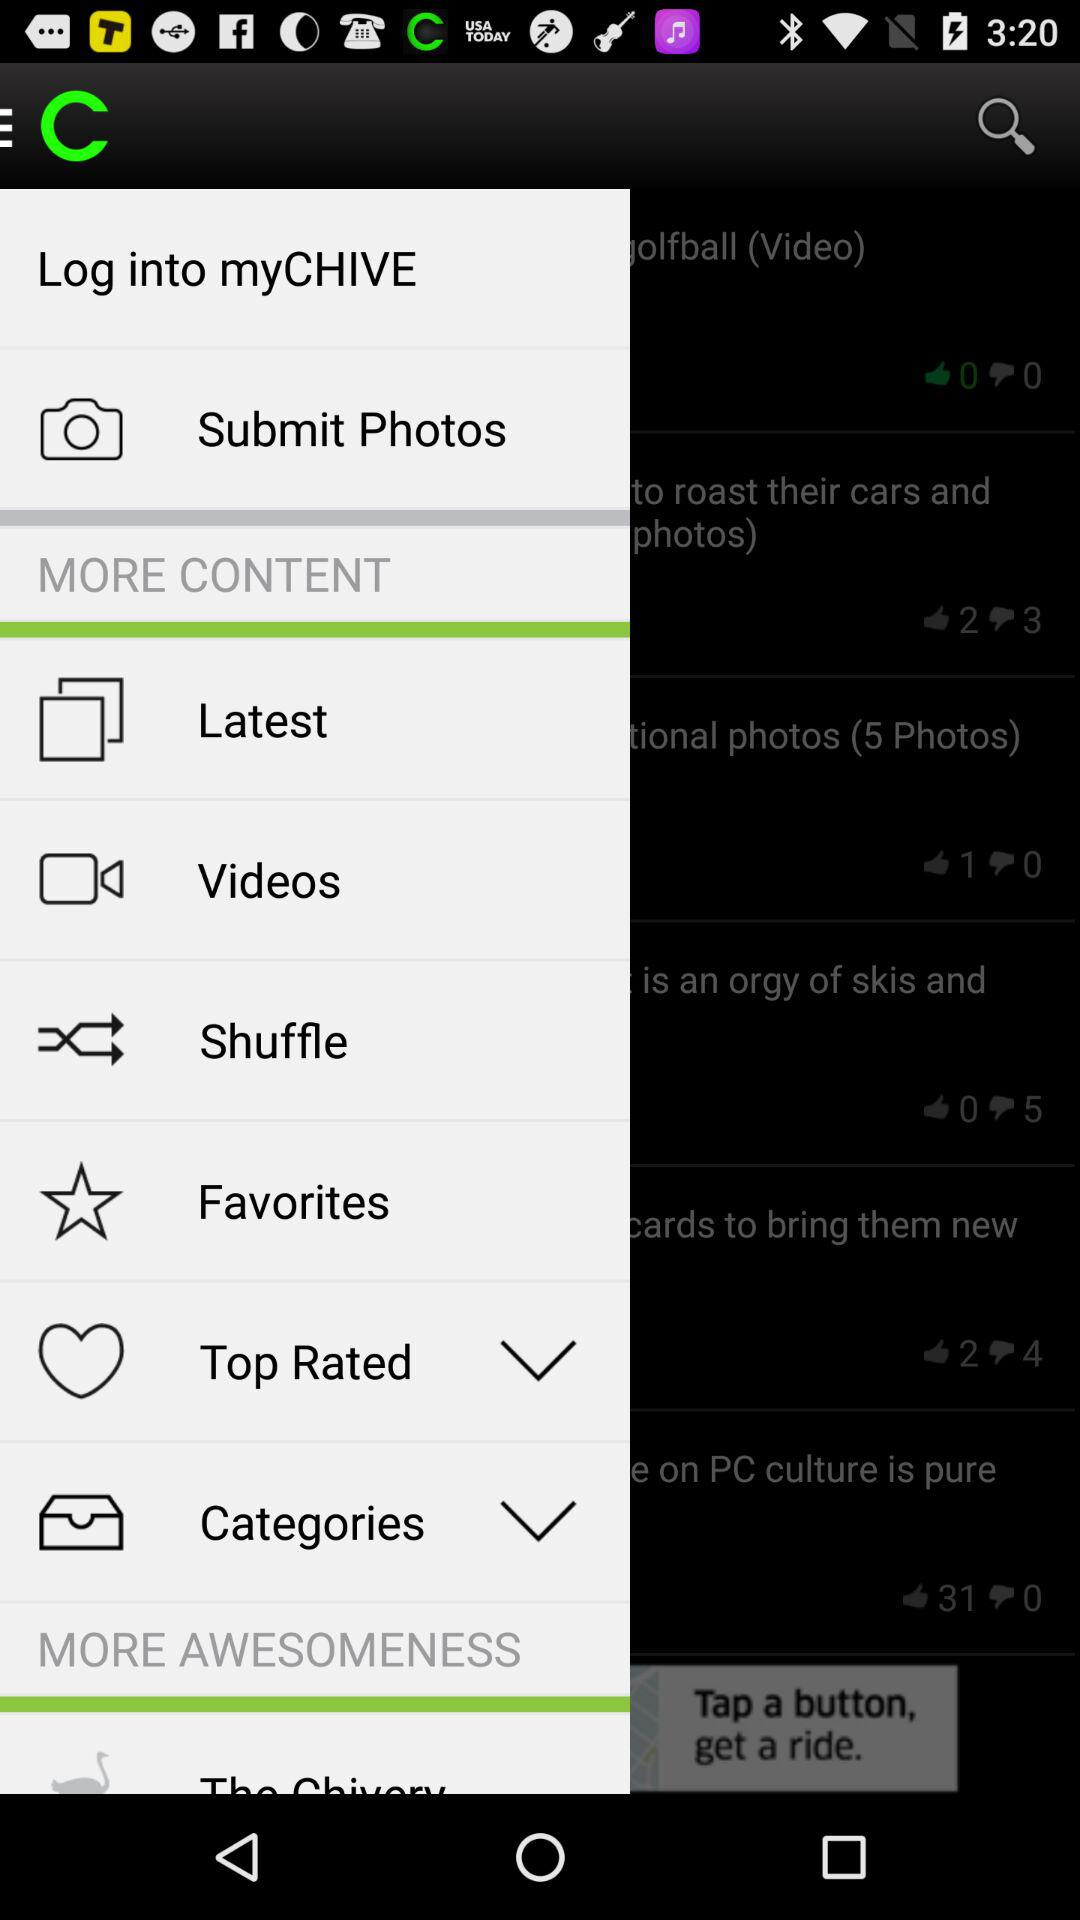What is the application name? The application name is "myCHIVE". 